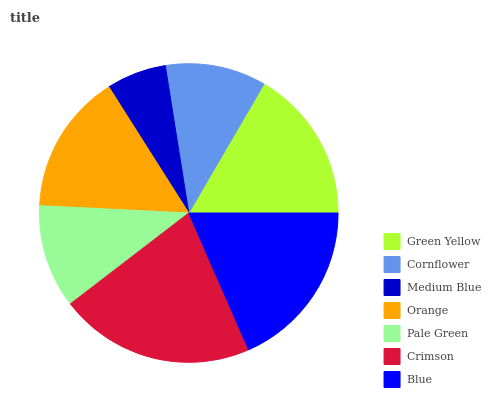Is Medium Blue the minimum?
Answer yes or no. Yes. Is Crimson the maximum?
Answer yes or no. Yes. Is Cornflower the minimum?
Answer yes or no. No. Is Cornflower the maximum?
Answer yes or no. No. Is Green Yellow greater than Cornflower?
Answer yes or no. Yes. Is Cornflower less than Green Yellow?
Answer yes or no. Yes. Is Cornflower greater than Green Yellow?
Answer yes or no. No. Is Green Yellow less than Cornflower?
Answer yes or no. No. Is Orange the high median?
Answer yes or no. Yes. Is Orange the low median?
Answer yes or no. Yes. Is Blue the high median?
Answer yes or no. No. Is Cornflower the low median?
Answer yes or no. No. 